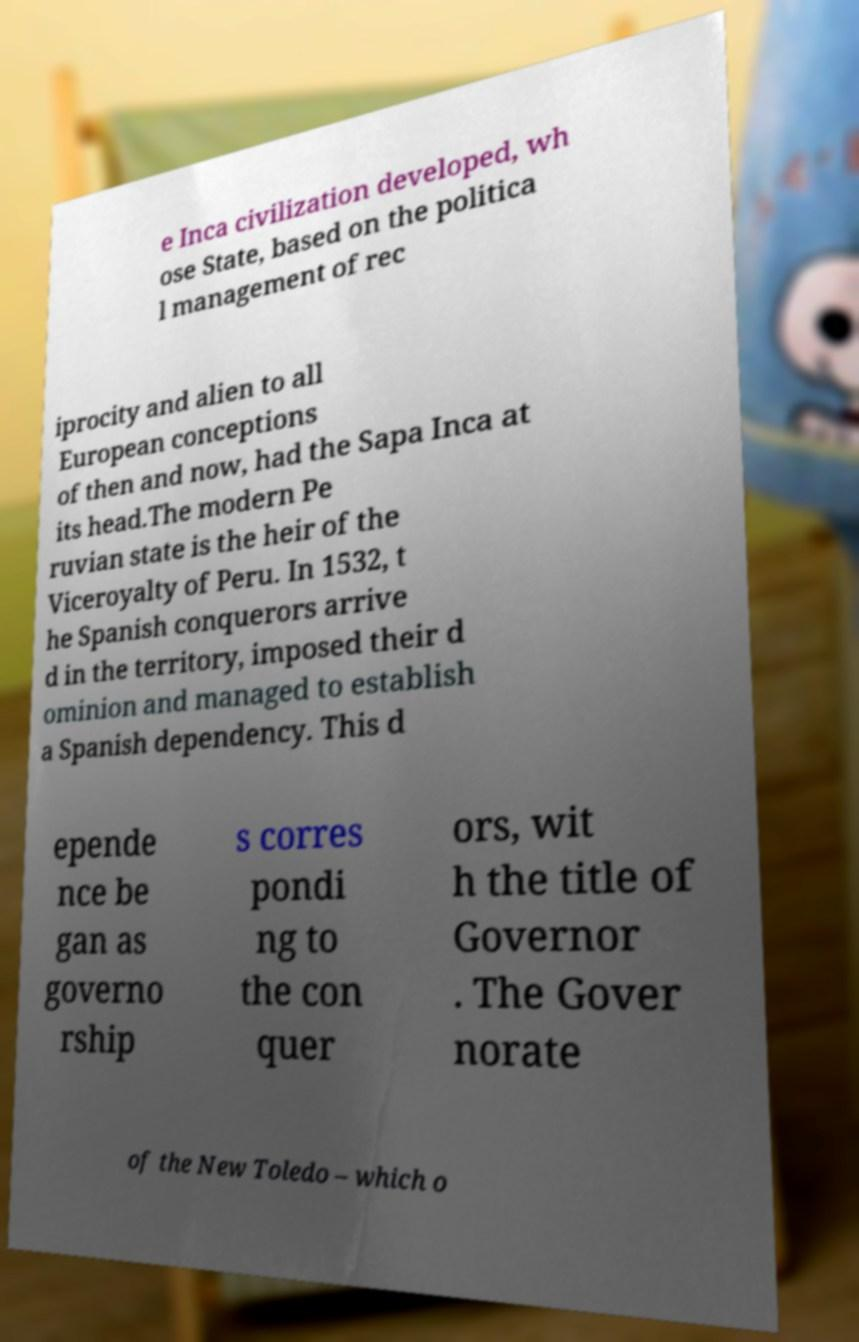Please identify and transcribe the text found in this image. e Inca civilization developed, wh ose State, based on the politica l management of rec iprocity and alien to all European conceptions of then and now, had the Sapa Inca at its head.The modern Pe ruvian state is the heir of the Viceroyalty of Peru. In 1532, t he Spanish conquerors arrive d in the territory, imposed their d ominion and managed to establish a Spanish dependency. This d epende nce be gan as governo rship s corres pondi ng to the con quer ors, wit h the title of Governor . The Gover norate of the New Toledo – which o 